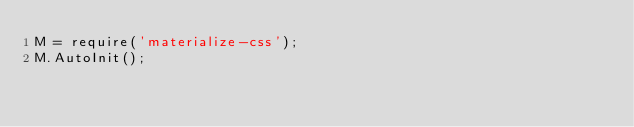<code> <loc_0><loc_0><loc_500><loc_500><_JavaScript_>M = require('materialize-css');
M.AutoInit();</code> 